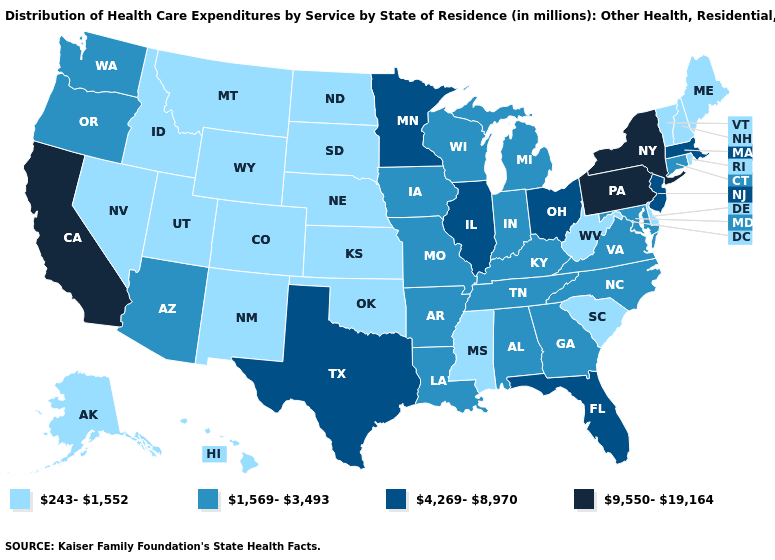Does Arkansas have a higher value than Montana?
Quick response, please. Yes. What is the value of Tennessee?
Give a very brief answer. 1,569-3,493. What is the lowest value in the USA?
Short answer required. 243-1,552. What is the value of Illinois?
Short answer required. 4,269-8,970. How many symbols are there in the legend?
Quick response, please. 4. Name the states that have a value in the range 4,269-8,970?
Write a very short answer. Florida, Illinois, Massachusetts, Minnesota, New Jersey, Ohio, Texas. Name the states that have a value in the range 4,269-8,970?
Be succinct. Florida, Illinois, Massachusetts, Minnesota, New Jersey, Ohio, Texas. Among the states that border Delaware , does Pennsylvania have the highest value?
Give a very brief answer. Yes. Among the states that border Arizona , which have the lowest value?
Be succinct. Colorado, Nevada, New Mexico, Utah. Name the states that have a value in the range 243-1,552?
Quick response, please. Alaska, Colorado, Delaware, Hawaii, Idaho, Kansas, Maine, Mississippi, Montana, Nebraska, Nevada, New Hampshire, New Mexico, North Dakota, Oklahoma, Rhode Island, South Carolina, South Dakota, Utah, Vermont, West Virginia, Wyoming. What is the lowest value in the West?
Be succinct. 243-1,552. Does the map have missing data?
Answer briefly. No. How many symbols are there in the legend?
Short answer required. 4. Among the states that border Ohio , does Kentucky have the highest value?
Concise answer only. No. What is the value of Florida?
Answer briefly. 4,269-8,970. 